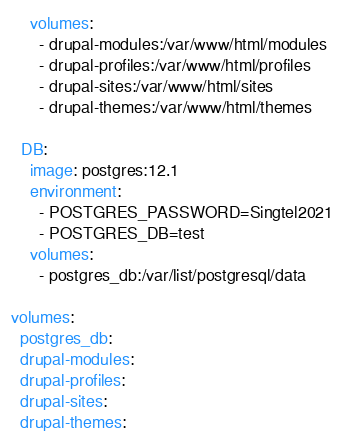Convert code to text. <code><loc_0><loc_0><loc_500><loc_500><_YAML_>    volumes:
      - drupal-modules:/var/www/html/modules
      - drupal-profiles:/var/www/html/profiles
      - drupal-sites:/var/www/html/sites
      - drupal-themes:/var/www/html/themes
    
  DB:
    image: postgres:12.1
    environment: 
      - POSTGRES_PASSWORD=Singtel2021
      - POSTGRES_DB=test
    volumes:
      - postgres_db:/var/list/postgresql/data

volumes:
  postgres_db:
  drupal-modules:
  drupal-profiles:
  drupal-sites:
  drupal-themes:
</code> 